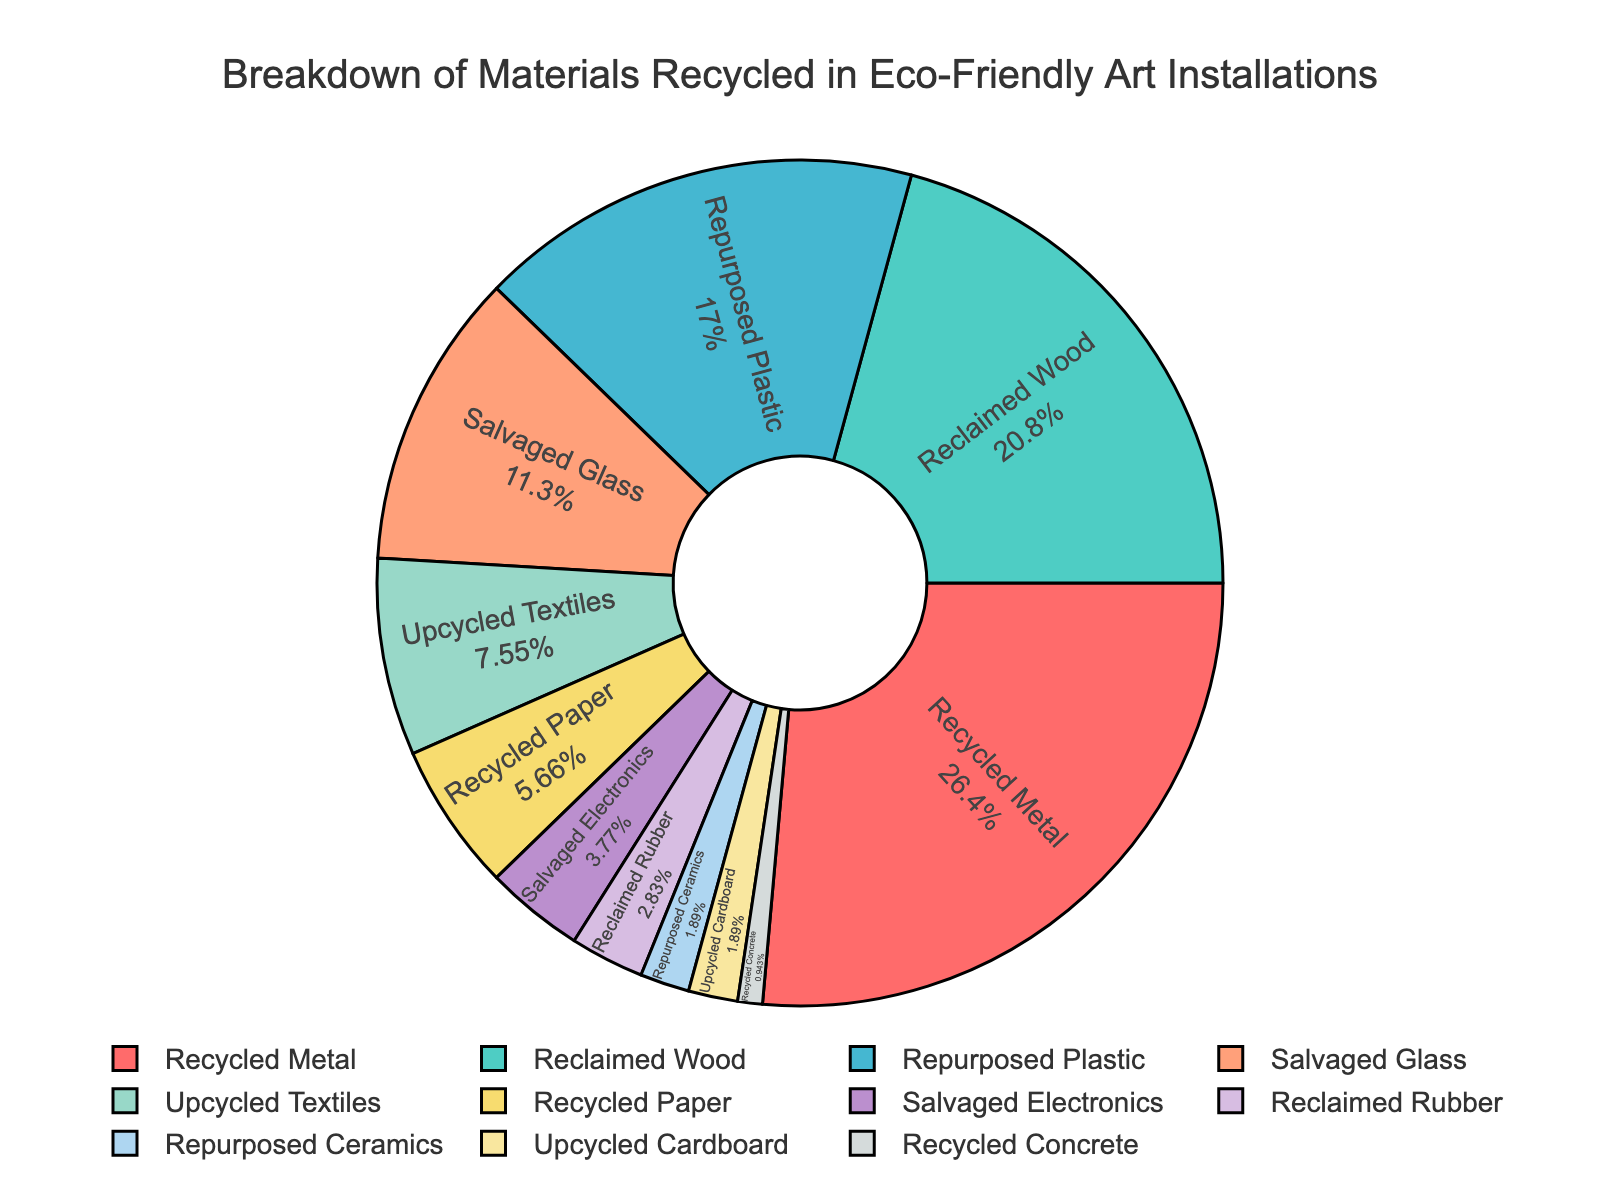which material has the highest percentage in the pie chart? The material with the highest percentage would have the greatest portion represented in the pie chart. According to the data, Recycled Metal has the highest percentage which is 28%.
Answer: Recycled Metal what is the total percentage of Reclaimed Wood and Repurposed Plastic? To find the total percentage, we sum up the individual percentages: Reclaimed Wood (22%) and Repurposed Plastic (18%). So, 22 + 18 = 40.
Answer: 40% what is the difference in percentage between the highest and lowest recycled materials? The highest is Recycled Metal at 28%, and the lowest is Recycled Concrete at 1%. Calculating the difference: 28 - 1 = 27.
Answer: 27% which materials have an equal percentage in the breakdown? By examining the data, we see that Repurposed Ceramics and Upcycled Cardboard each have 2%, making them equal.
Answer: Repurposed Ceramics and Upcycled Cardboard what is the combined percentage of all materials contributing less than 5% each? To calculate this, sum the percentages for Salvaged Electronics (4%), Reclaimed Rubber (3%), Repurposed Ceramics (2%), Upcycled Cardboard (2%), and Recycled Concrete (1%). So, 4 + 3 + 2 + 2 + 1 = 12.
Answer: 12% which color represents Reclaimed Wood in the pie chart? Analyzing the color scheme provided for each material, Reclaimed Wood is likely associated with the second color listed, which is '#4ECDC4', corresponding to a greenish blue.
Answer: Greenish blue how much greater is the percentage of Recycled Metal compared to Salvaged Glass? To find out how much greater, subtract Salvaged Glass's percentage (12%) from Recycled Metal's percentage (28%). So, 28 - 12 = 16.
Answer: 16% what percentage of the pie chart is made up of Upcycled Textiles and Recycled Paper? Add the percentages of Upcycled Textiles (8%) and Recycled Paper (6%). So, 8 + 6 = 14.
Answer: 14% which segment is the smallest, and what is its percentage? The smallest segment in the pie chart is Recycled Concrete with a percentage of 1%.
Answer: Recycled Concrete, 1% is the percentage of Repurposed Plastic more or less than the percentage of Reclaimed Wood? According to the data, Repurposed Plastic has 18% while Reclaimed Wood has 22%. Repurposed Plastic is less than Reclaimed Wood.
Answer: Less 